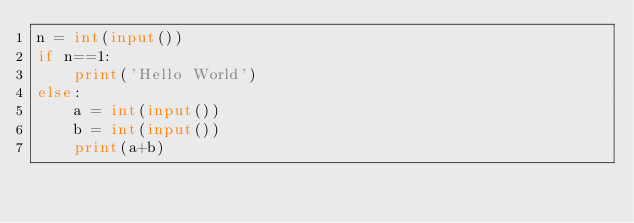Convert code to text. <code><loc_0><loc_0><loc_500><loc_500><_Python_>n = int(input())
if n==1:
    print('Hello World')
else:
    a = int(input())
    b = int(input())
    print(a+b)
</code> 